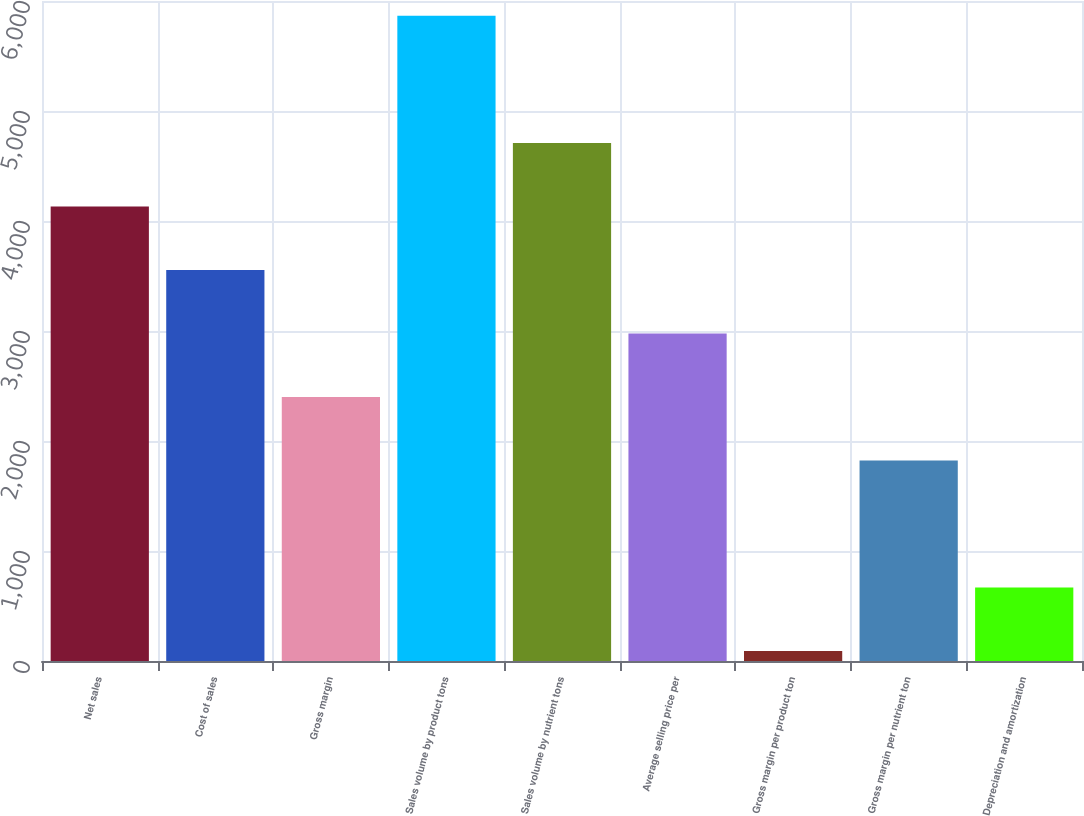Convert chart to OTSL. <chart><loc_0><loc_0><loc_500><loc_500><bar_chart><fcel>Net sales<fcel>Cost of sales<fcel>Gross margin<fcel>Sales volume by product tons<fcel>Sales volume by nutrient tons<fcel>Average selling price per<fcel>Gross margin per product ton<fcel>Gross margin per nutrient ton<fcel>Depreciation and amortization<nl><fcel>4132.5<fcel>3555<fcel>2400<fcel>5865<fcel>4710<fcel>2977.5<fcel>90<fcel>1822.5<fcel>667.5<nl></chart> 